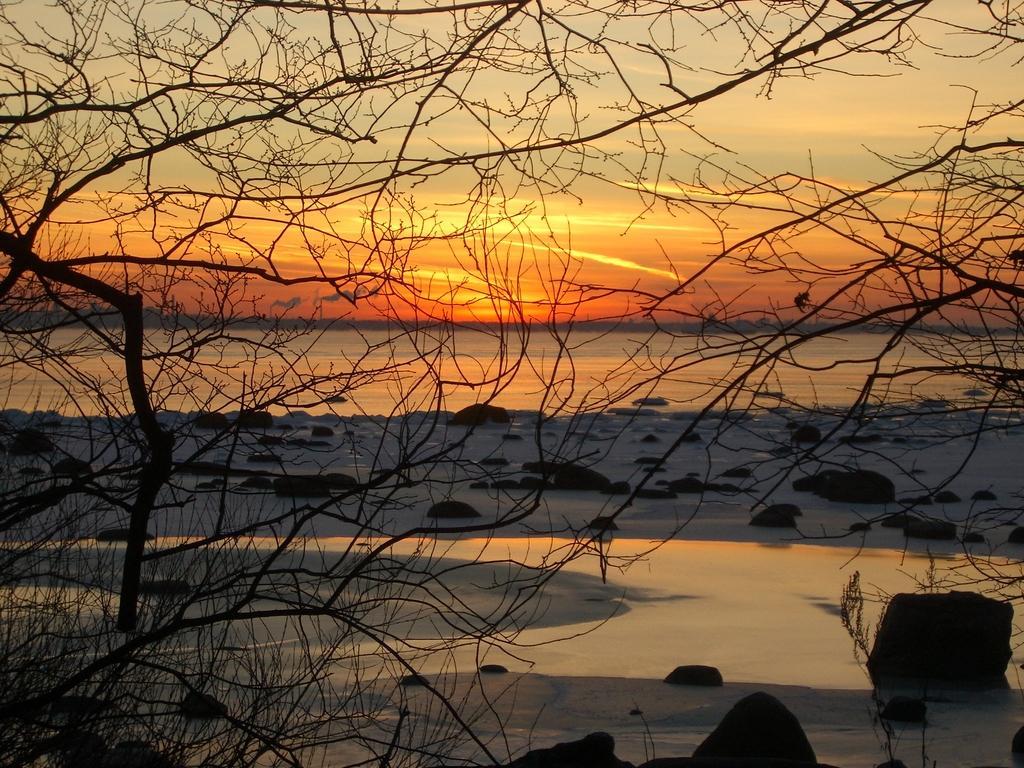How would you summarize this image in a sentence or two? In this image we can see trees, water, rocks, sunlight and the sky in the background. 